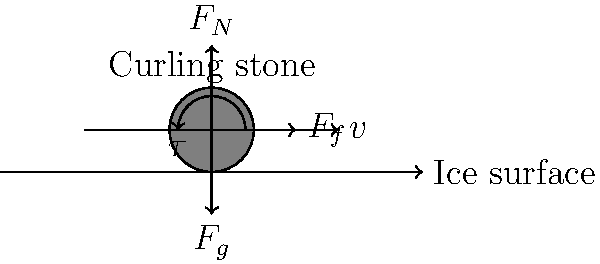In the diagram above, which force is responsible for the curling stone's characteristic curved path on the ice, and how does it relate to the stone's rotation? To understand the curling stone's curved path, let's analyze the forces acting on it:

1. $F_g$: Gravitational force pulling the stone downward
2. $F_N$: Normal force from the ice surface supporting the stone
3. $F_f$: Friction force opposing the stone's motion
4. $\tau$: Rotational force (torque) causing the stone to spin

The key to the stone's curved path lies in the interaction between the rotating stone and the ice surface. This phenomenon is known as curl or curl effect.

Step-by-step explanation:

1. As the stone slides, it rotates due to the initial spin given by the player.
2. The rotation causes asymmetric friction between the stone's running band (bottom edge) and the ice.
3. This asymmetric friction is due to the pebbled ice surface and the stone's rotation.
4. The side of the stone rotating into the direction of motion experiences slightly more friction than the opposite side.
5. This difference in friction creates a sideways force, perpendicular to the stone's motion.
6. This sideways force, often called the curl force, is responsible for the stone's curved path.

The curl force is not explicitly shown in the diagram but is a result of the interaction between the rotational force $\tau$ and the friction force $F_f$.

The amount of curl depends on:
- The stone's rotational speed
- The stone's velocity
- Ice conditions

In conclusion, the curl force, resulting from the asymmetric friction caused by the stone's rotation, is responsible for the characteristic curved path in curling.
Answer: Curl force (asymmetric friction due to rotation) 